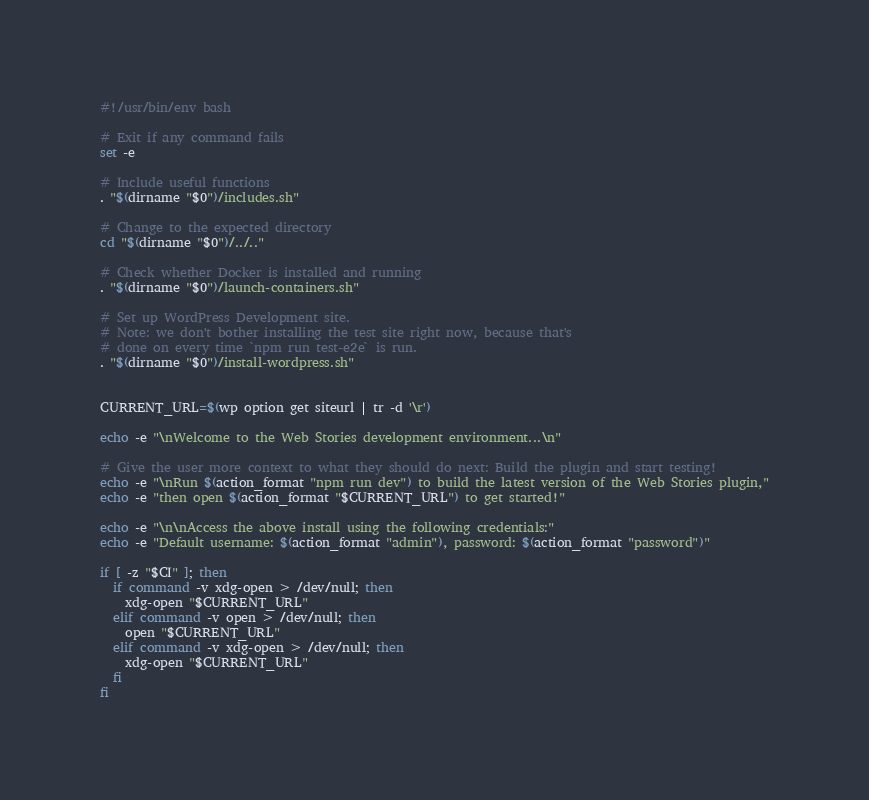Convert code to text. <code><loc_0><loc_0><loc_500><loc_500><_Bash_>#!/usr/bin/env bash

# Exit if any command fails
set -e

# Include useful functions
. "$(dirname "$0")/includes.sh"

# Change to the expected directory
cd "$(dirname "$0")/../.."

# Check whether Docker is installed and running
. "$(dirname "$0")/launch-containers.sh"

# Set up WordPress Development site.
# Note: we don't bother installing the test site right now, because that's
# done on every time `npm run test-e2e` is run.
. "$(dirname "$0")/install-wordpress.sh"


CURRENT_URL=$(wp option get siteurl | tr -d '\r')

echo -e "\nWelcome to the Web Stories development environment...\n"

# Give the user more context to what they should do next: Build the plugin and start testing!
echo -e "\nRun $(action_format "npm run dev") to build the latest version of the Web Stories plugin,"
echo -e "then open $(action_format "$CURRENT_URL") to get started!"

echo -e "\n\nAccess the above install using the following credentials:"
echo -e "Default username: $(action_format "admin"), password: $(action_format "password")"

if [ -z "$CI" ]; then
  if command -v xdg-open > /dev/null; then
    xdg-open "$CURRENT_URL"
  elif command -v open > /dev/null; then
    open "$CURRENT_URL"
  elif command -v xdg-open > /dev/null; then
    xdg-open "$CURRENT_URL"
  fi
fi
</code> 